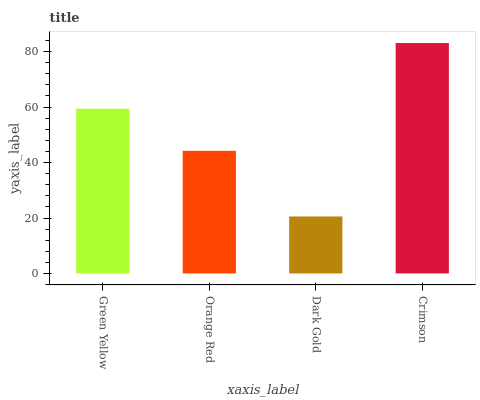Is Dark Gold the minimum?
Answer yes or no. Yes. Is Crimson the maximum?
Answer yes or no. Yes. Is Orange Red the minimum?
Answer yes or no. No. Is Orange Red the maximum?
Answer yes or no. No. Is Green Yellow greater than Orange Red?
Answer yes or no. Yes. Is Orange Red less than Green Yellow?
Answer yes or no. Yes. Is Orange Red greater than Green Yellow?
Answer yes or no. No. Is Green Yellow less than Orange Red?
Answer yes or no. No. Is Green Yellow the high median?
Answer yes or no. Yes. Is Orange Red the low median?
Answer yes or no. Yes. Is Crimson the high median?
Answer yes or no. No. Is Dark Gold the low median?
Answer yes or no. No. 